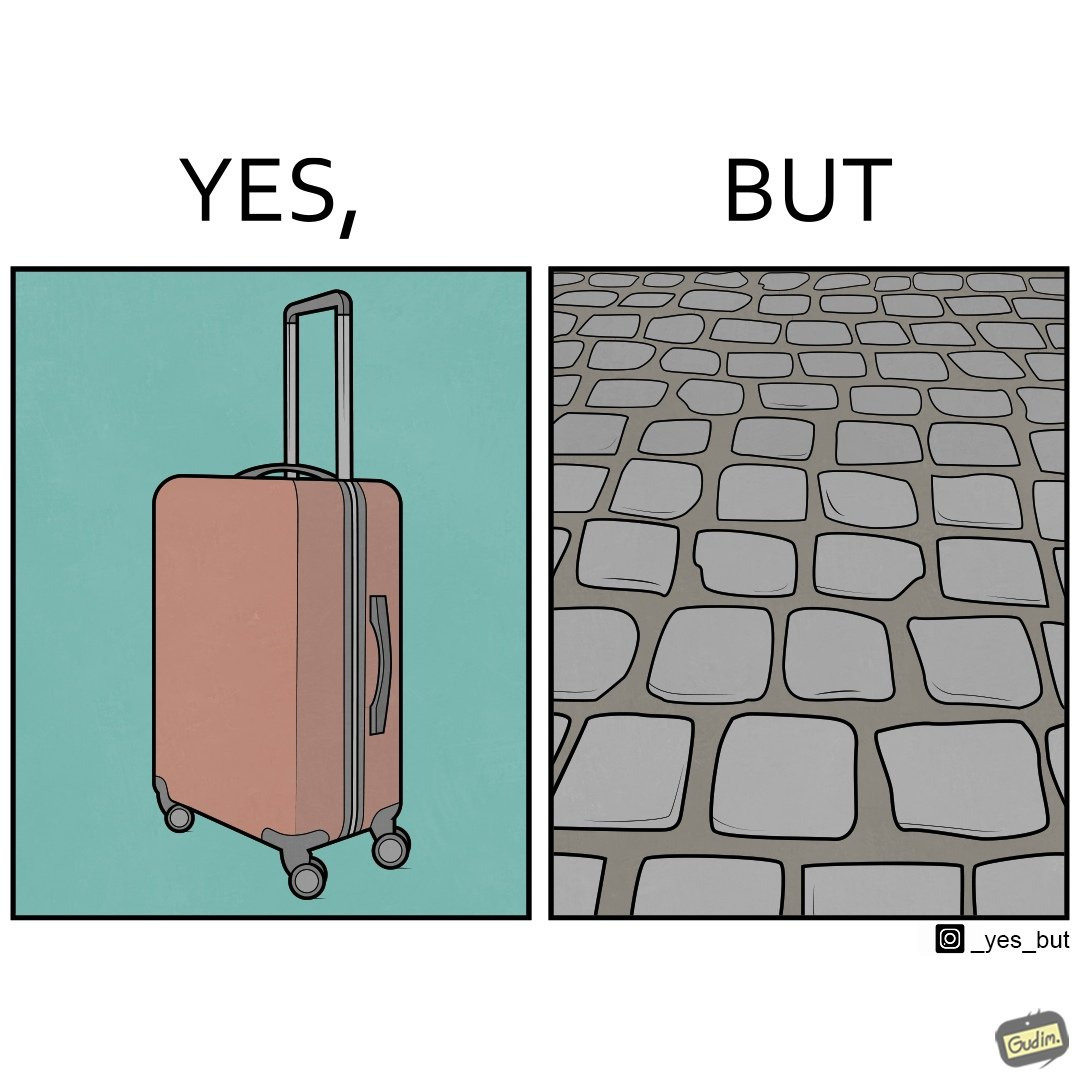Describe the content of this image. The image is funny because even though the trolley bag is made to make carrying luggage easy, as soon as it encounters a rough surface like cobblestone road, it makes carrying luggage more difficult. 